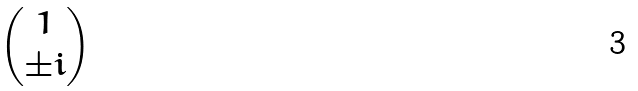Convert formula to latex. <formula><loc_0><loc_0><loc_500><loc_500>\begin{pmatrix} 1 \\ \pm i \end{pmatrix}</formula> 